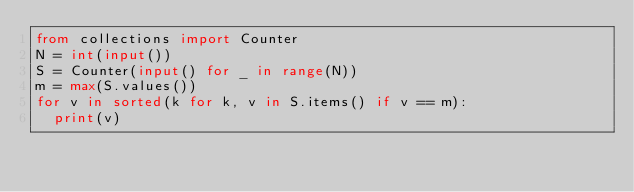Convert code to text. <code><loc_0><loc_0><loc_500><loc_500><_Python_>from collections import Counter
N = int(input())
S = Counter(input() for _ in range(N))
m = max(S.values())
for v in sorted(k for k, v in S.items() if v == m):
	print(v)
</code> 